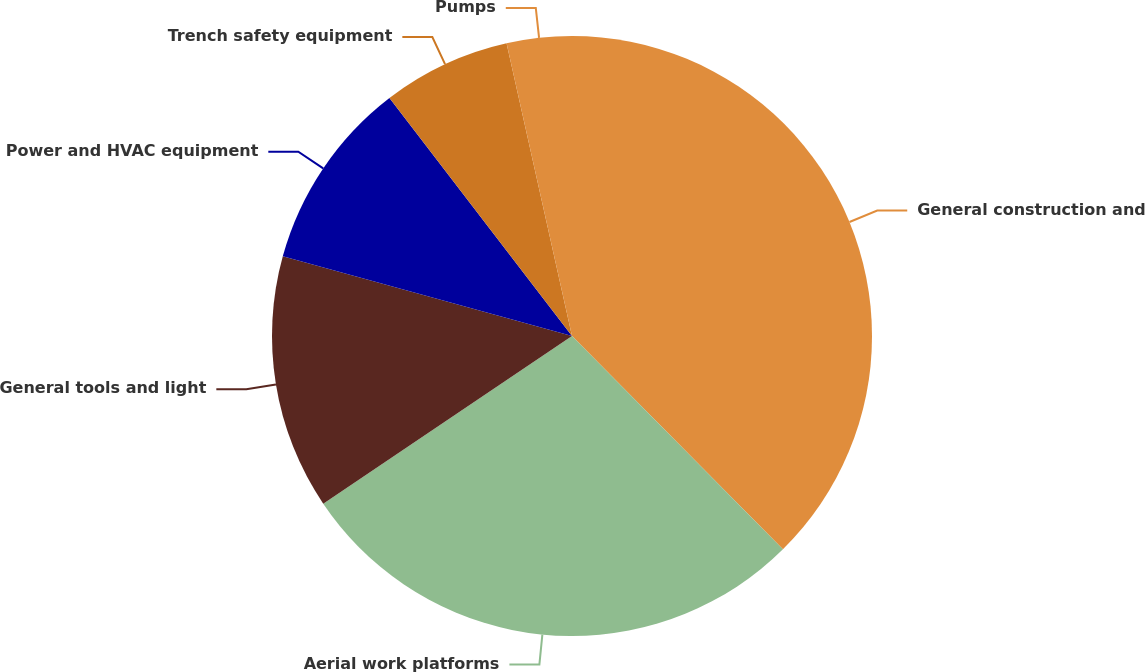<chart> <loc_0><loc_0><loc_500><loc_500><pie_chart><fcel>General construction and<fcel>Aerial work platforms<fcel>General tools and light<fcel>Power and HVAC equipment<fcel>Trench safety equipment<fcel>Pumps<nl><fcel>37.59%<fcel>27.97%<fcel>13.72%<fcel>10.31%<fcel>6.91%<fcel>3.5%<nl></chart> 